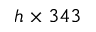<formula> <loc_0><loc_0><loc_500><loc_500>h \times 3 4 3</formula> 